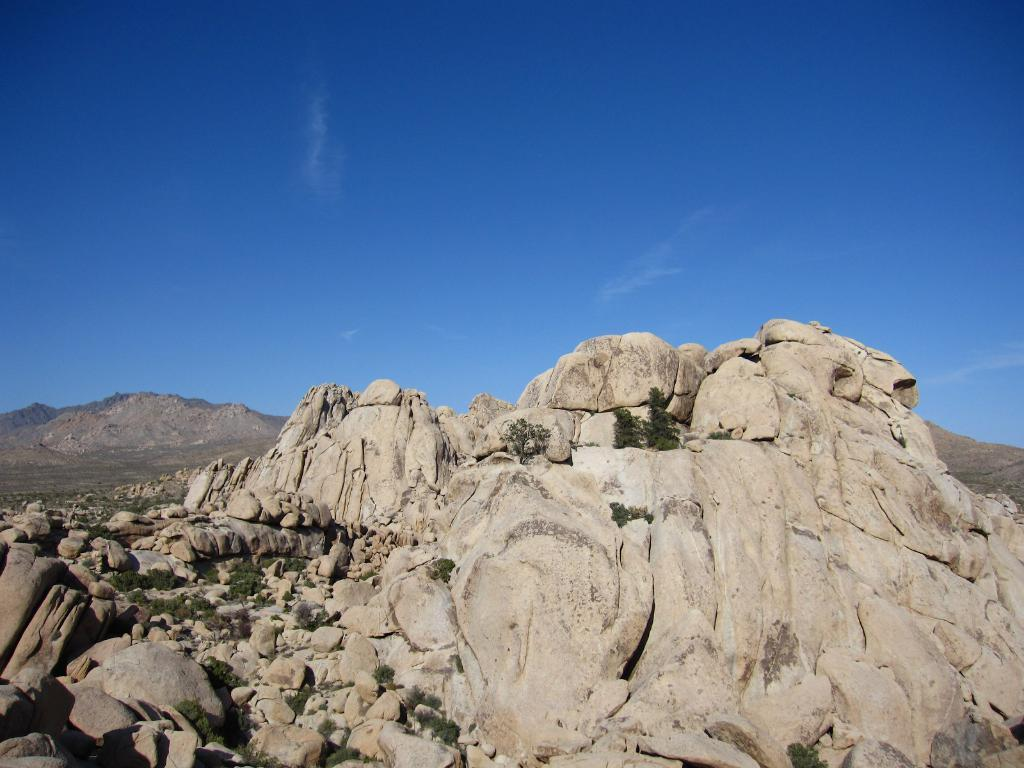What type of natural elements can be seen in the image? There are rocks and plants in the image. What can be seen in the background of the image? The sky is visible in the background of the image. What type of potato is being used to answer questions in the image? There is no potato present in the image, nor is there any indication that potatoes are being used to answer questions. 